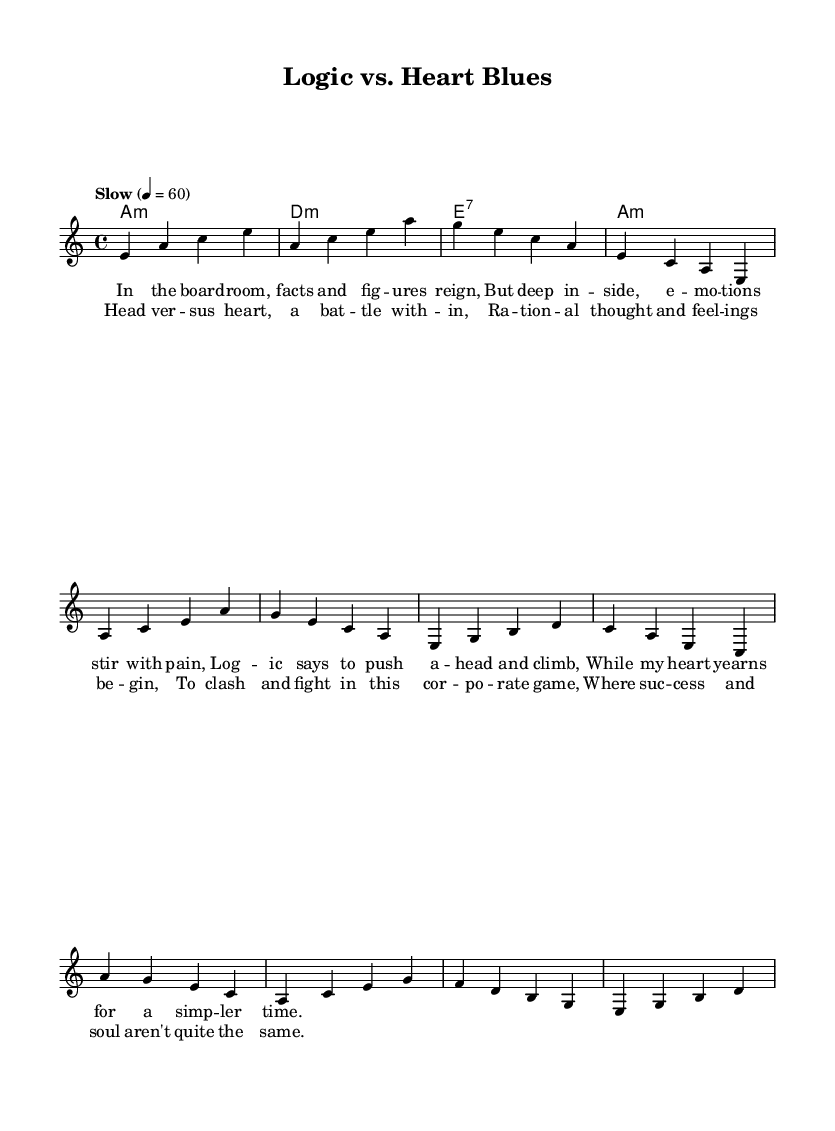What is the key signature of this music? The key signature is A minor, which has no sharps or flats. To identify the key signature, we look at the score and see that it is explicitly labeled as "a", indicating A minor.
Answer: A minor What is the time signature of this piece? The time signature is 4/4, which means there are four beats in a measure, and a quarter note gets one beat. This can be confirmed by observing the "4/4" marked on the score.
Answer: 4/4 What is the tempo marking indicated in the sheet music? The tempo marking is "Slow" with a metronome marking of 60 beats per minute. This information is clearly provided in the score, noting the desired speed of the piece.
Answer: Slow 4 = 60 Identify the first chord in the harmony part. The first chord is A minor. In the chord section of the score, it marks "a1:m" as the first chord, corresponding to A minor.
Answer: A minor What is the main theme explored in the lyrics? The main theme is the conflict between logic and emotion. By reading the lyrics, we see references to the challenges of balancing rational thoughts with emotional responses in a corporate setting.
Answer: Conflict between logic and emotion How many measures are there in the chorus section? There are 4 measures in the chorus section, as noted in the way the chords and melody are laid out in the score, indicating a transition with 4 lines of text.
Answer: 4 What is the underlying emotional tension described in the lyrics? The underlying emotional tension is the battle between rational thought and feelings. The lyrics explicitly illustrate this struggle, highlighting the discord inherent in professional environments while striving for success.
Answer: Battle between rational thought and feelings 